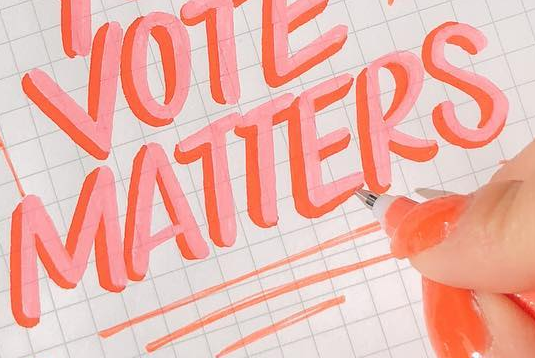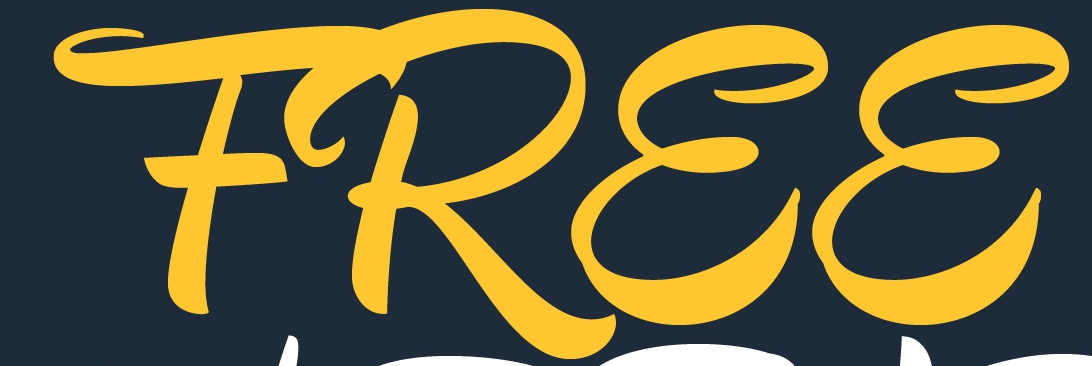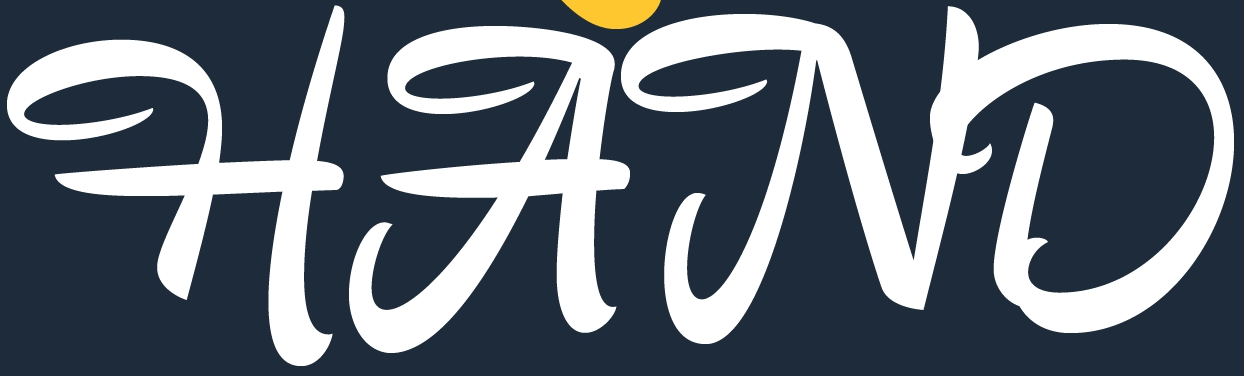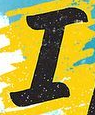Transcribe the words shown in these images in order, separated by a semicolon. MATTERS; FREE; HAND; I 